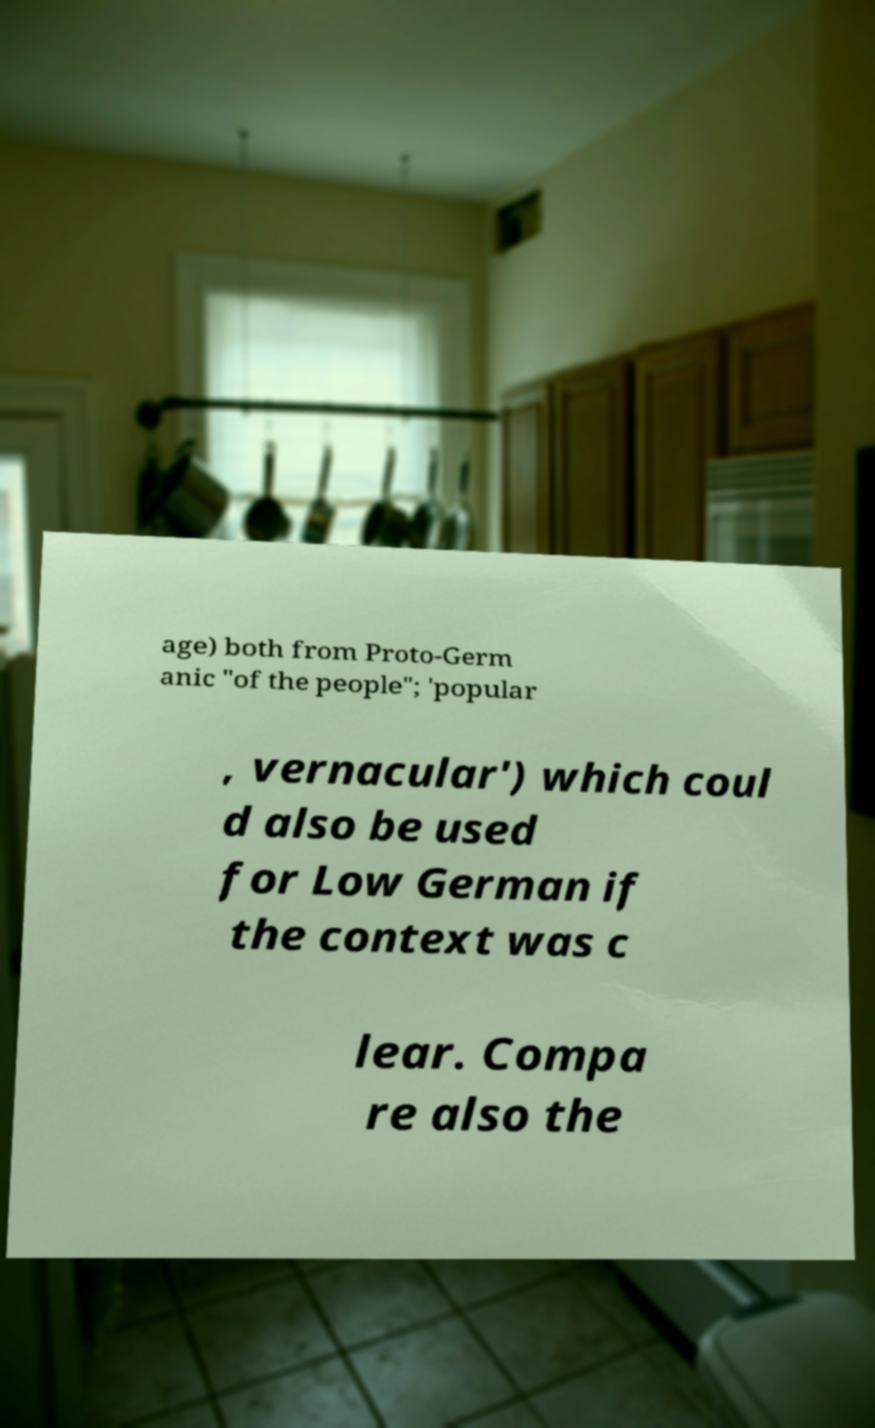What messages or text are displayed in this image? I need them in a readable, typed format. age) both from Proto-Germ anic "of the people"; 'popular , vernacular') which coul d also be used for Low German if the context was c lear. Compa re also the 